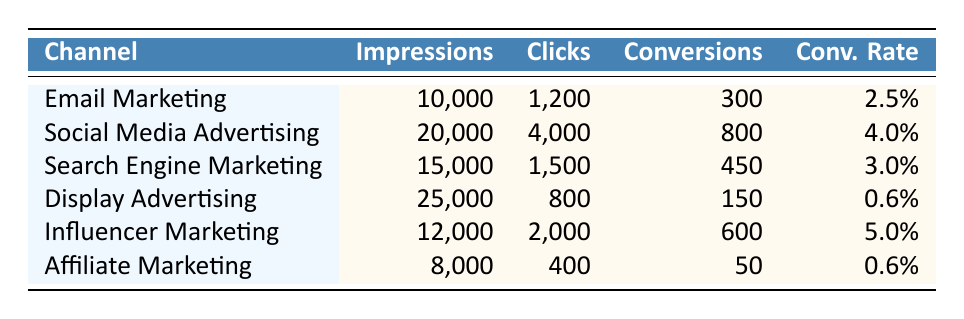What is the conversion rate for Email Marketing? The table shows that the conversion rate for Email Marketing is listed directly in the last column corresponding to the "Email Marketing" row. It indicates a conversion rate of 2.5%.
Answer: 2.5% Which advertising channel had the highest number of conversions? By reviewing the "Conversions" column in the table, Social Media Advertising has the highest value, showing 800 conversions.
Answer: Social Media Advertising How many total impressions were made across all advertising channels? To find the total impressions, we sum the values from the "Impressions" column: 10,000 + 20,000 + 15,000 + 25,000 + 12,000 + 8,000 = 90,000.
Answer: 90,000 Is it true that Affiliate Marketing had more clicks than Display Advertising? By comparing the "Clicks" values for Affiliate Marketing (400) and Display Advertising (800), we can see that Affiliate Marketing had fewer clicks. Thus, the statement is false.
Answer: No What is the average conversion rate of all the advertising channels? The average conversion rate is calculated by first converting the percentages to decimal form (2.5% = 0.025, 4% = 0.04, etc.), summing them (0.025 + 0.04 + 0.03 + 0.006 + 0.05 + 0.006 = 0.157), and then dividing by the number of channels (6). This gives 0.157/6 ≈ 0.02617, which corresponds to approximately 2.62%.
Answer: 2.62% Which advertising channel had the lowest conversion rate? The table lists the conversion rates, and by comparison, we can see that both Display Advertising and Affiliate Marketing share the lowest conversion rate at 0.6%.
Answer: Display Advertising and Affiliate Marketing How many total conversions were achieved through Influencer Marketing and Search Engine Marketing combined? To find the total conversions for both Influencer Marketing (600) and Search Engine Marketing (450), we add these two values: 600 + 450 = 1,050.
Answer: 1,050 Is the conversion rate for Social Media Advertising greater than that of Search Engine Marketing? According to the table, Social Media Advertising has a conversion rate of 4.0%, while Search Engine Marketing has 3.0%. Since 4.0% is greater than 3.0%, the statement is true.
Answer: Yes 